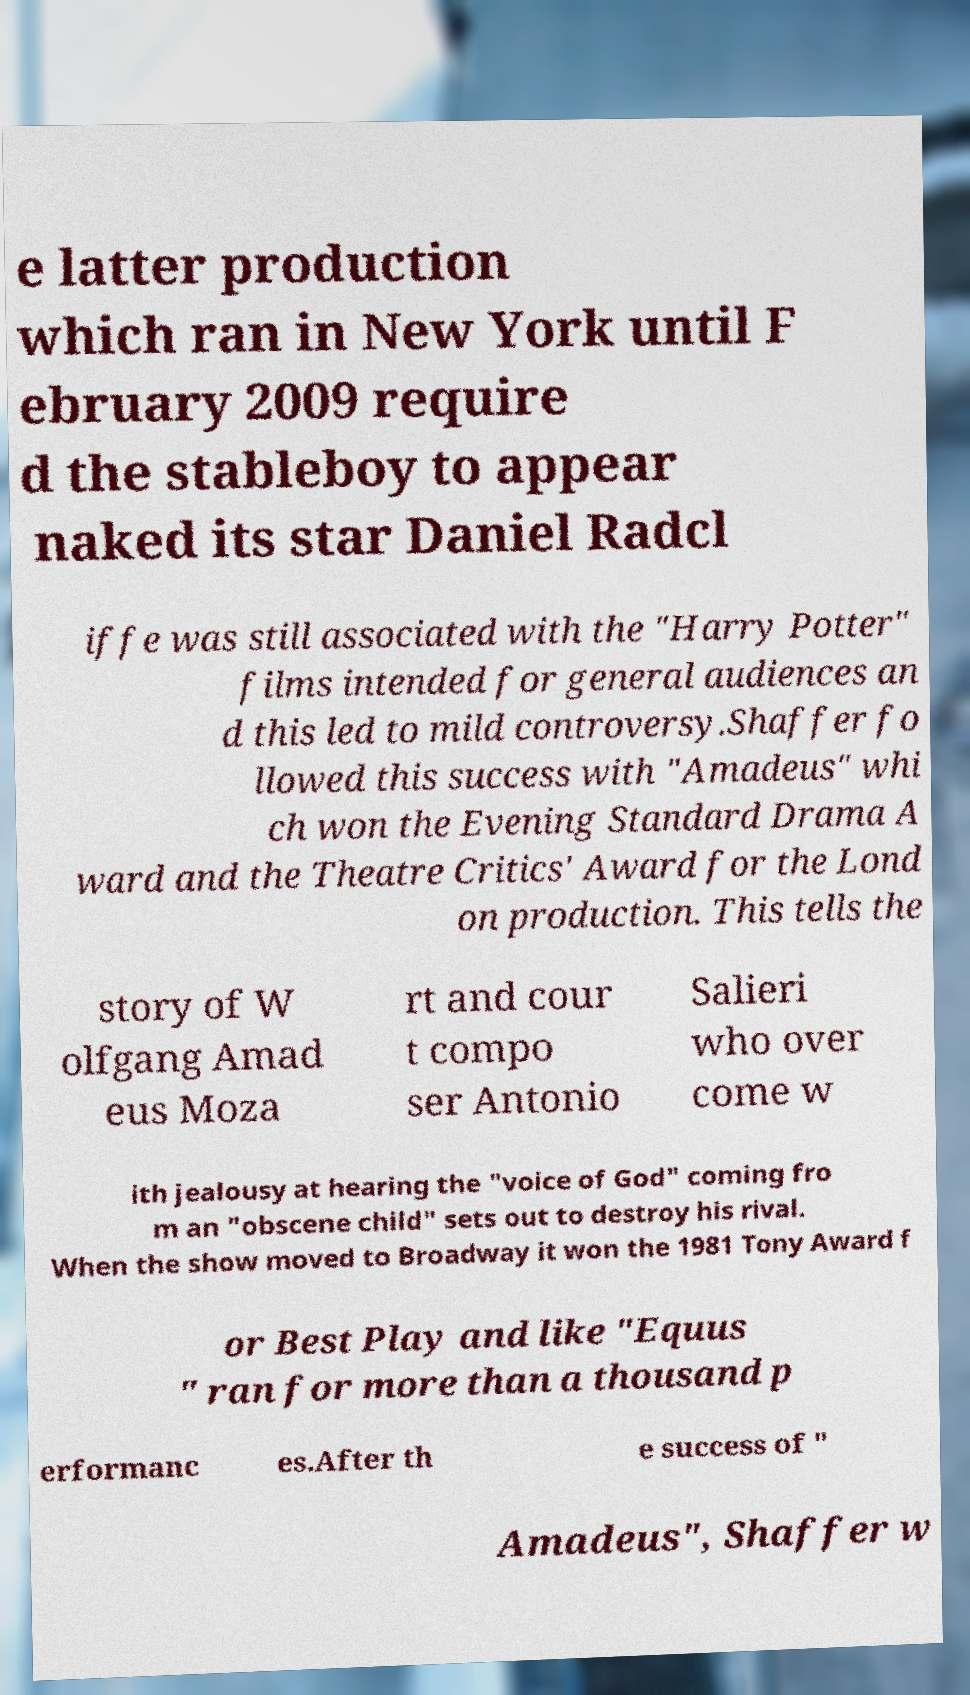Could you extract and type out the text from this image? e latter production which ran in New York until F ebruary 2009 require d the stableboy to appear naked its star Daniel Radcl iffe was still associated with the "Harry Potter" films intended for general audiences an d this led to mild controversy.Shaffer fo llowed this success with "Amadeus" whi ch won the Evening Standard Drama A ward and the Theatre Critics' Award for the Lond on production. This tells the story of W olfgang Amad eus Moza rt and cour t compo ser Antonio Salieri who over come w ith jealousy at hearing the "voice of God" coming fro m an "obscene child" sets out to destroy his rival. When the show moved to Broadway it won the 1981 Tony Award f or Best Play and like "Equus " ran for more than a thousand p erformanc es.After th e success of " Amadeus", Shaffer w 